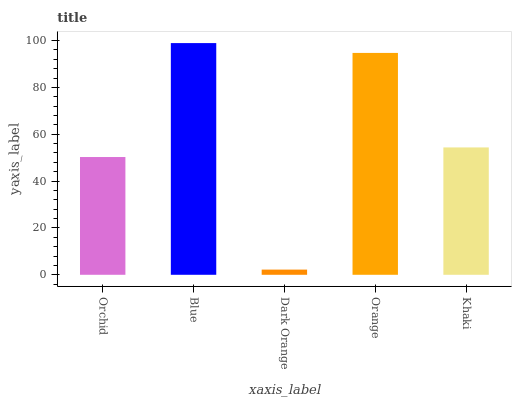Is Dark Orange the minimum?
Answer yes or no. Yes. Is Blue the maximum?
Answer yes or no. Yes. Is Blue the minimum?
Answer yes or no. No. Is Dark Orange the maximum?
Answer yes or no. No. Is Blue greater than Dark Orange?
Answer yes or no. Yes. Is Dark Orange less than Blue?
Answer yes or no. Yes. Is Dark Orange greater than Blue?
Answer yes or no. No. Is Blue less than Dark Orange?
Answer yes or no. No. Is Khaki the high median?
Answer yes or no. Yes. Is Khaki the low median?
Answer yes or no. Yes. Is Orange the high median?
Answer yes or no. No. Is Dark Orange the low median?
Answer yes or no. No. 